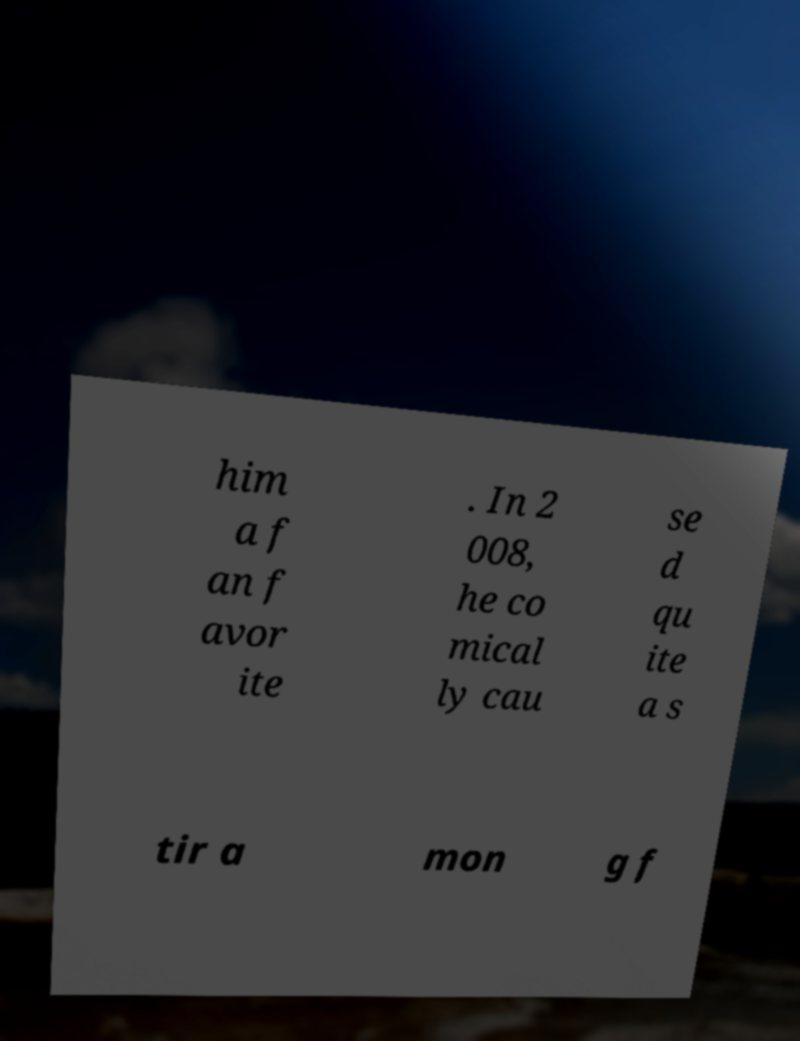Please read and relay the text visible in this image. What does it say? him a f an f avor ite . In 2 008, he co mical ly cau se d qu ite a s tir a mon g f 